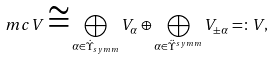<formula> <loc_0><loc_0><loc_500><loc_500>\ m c V \cong \bigoplus _ { \alpha \in \dot { \Upsilon } _ { s y m m } } V _ { \alpha } \oplus \bigoplus _ { \alpha \in \ddot { \Upsilon } ^ { s y m m } } V _ { \pm \alpha } = \colon V ,</formula> 